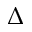<formula> <loc_0><loc_0><loc_500><loc_500>\Delta</formula> 